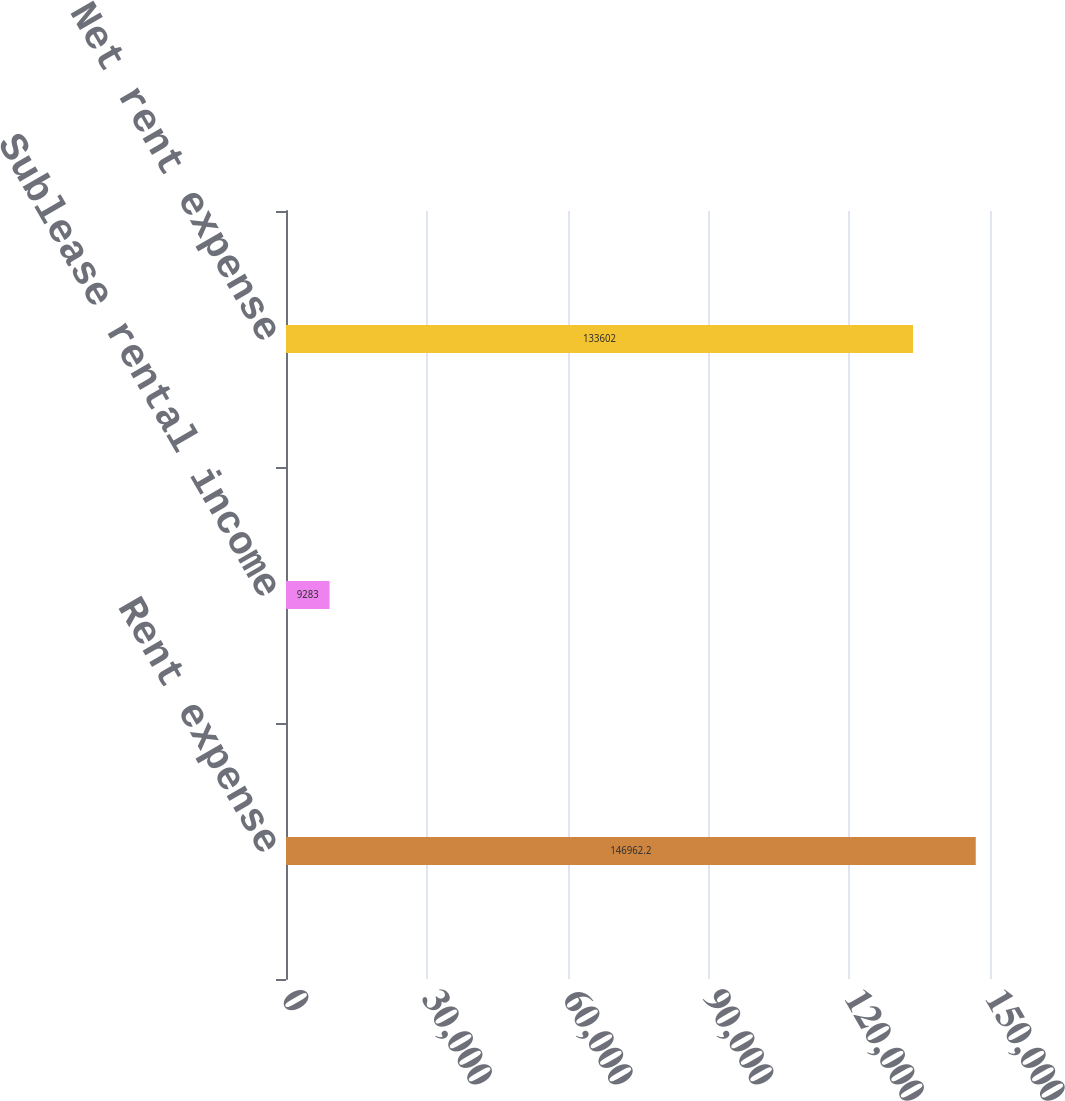Convert chart to OTSL. <chart><loc_0><loc_0><loc_500><loc_500><bar_chart><fcel>Rent expense<fcel>Sublease rental income<fcel>Net rent expense<nl><fcel>146962<fcel>9283<fcel>133602<nl></chart> 